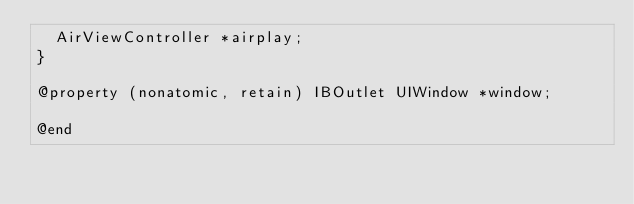<code> <loc_0><loc_0><loc_500><loc_500><_C_>	AirViewController *airplay;
}

@property (nonatomic, retain) IBOutlet UIWindow *window;

@end
</code> 